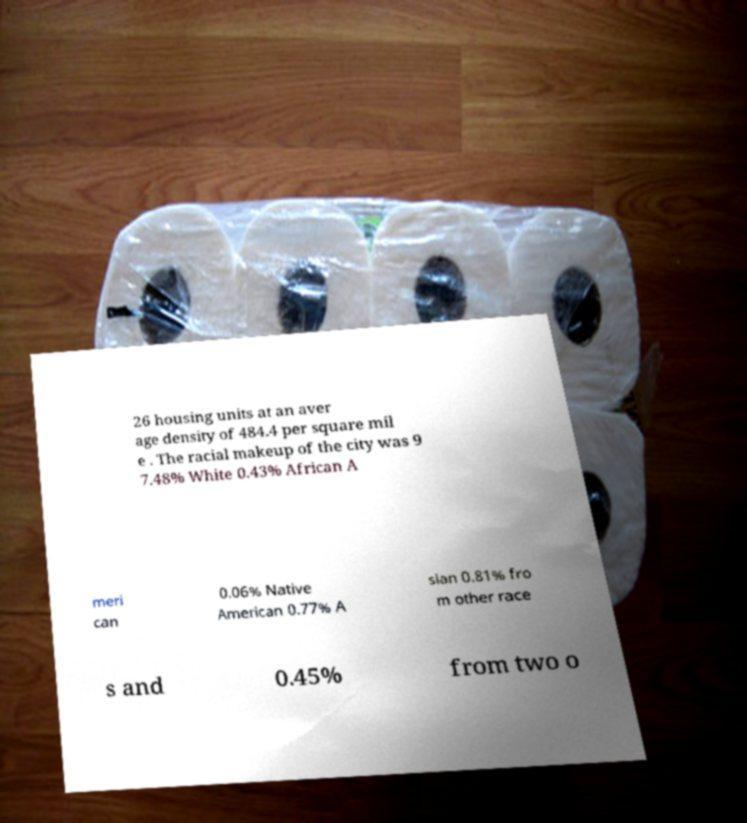Can you read and provide the text displayed in the image?This photo seems to have some interesting text. Can you extract and type it out for me? 26 housing units at an aver age density of 484.4 per square mil e . The racial makeup of the city was 9 7.48% White 0.43% African A meri can 0.06% Native American 0.77% A sian 0.81% fro m other race s and 0.45% from two o 